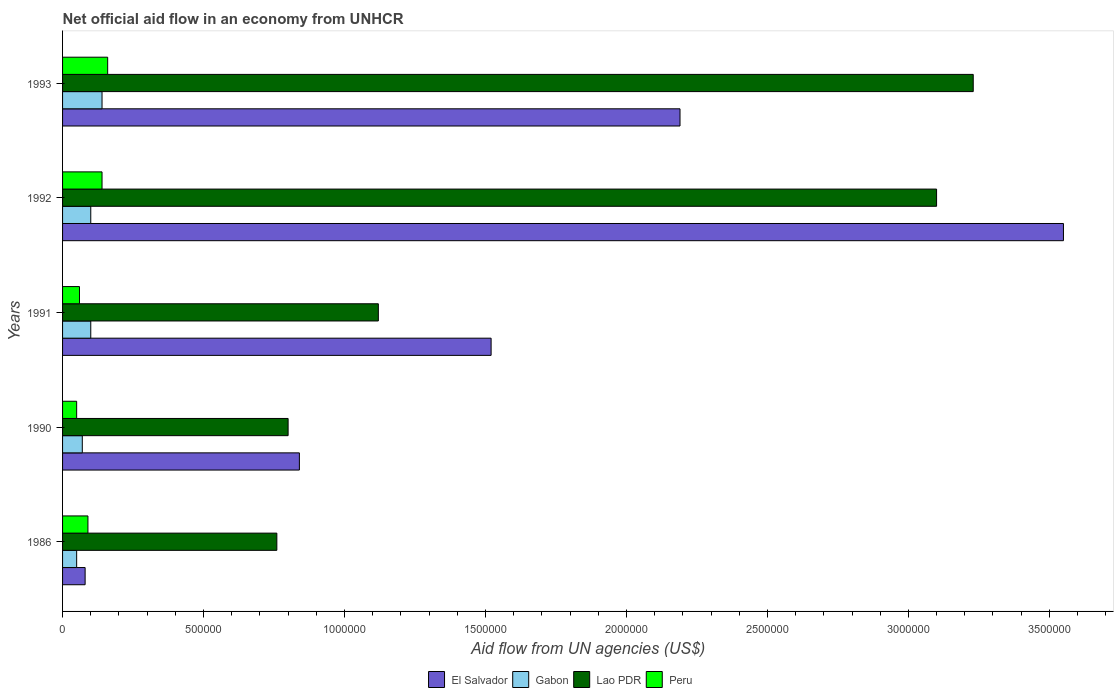How many different coloured bars are there?
Keep it short and to the point. 4. Are the number of bars per tick equal to the number of legend labels?
Make the answer very short. Yes. Are the number of bars on each tick of the Y-axis equal?
Your answer should be compact. Yes. What is the label of the 4th group of bars from the top?
Provide a short and direct response. 1990. What is the net official aid flow in Lao PDR in 1986?
Your response must be concise. 7.60e+05. Across all years, what is the maximum net official aid flow in El Salvador?
Offer a very short reply. 3.55e+06. In which year was the net official aid flow in El Salvador minimum?
Your response must be concise. 1986. What is the difference between the net official aid flow in Gabon in 1990 and that in 1991?
Your answer should be compact. -3.00e+04. What is the difference between the net official aid flow in Gabon in 1993 and the net official aid flow in Peru in 1991?
Your answer should be compact. 8.00e+04. What is the average net official aid flow in El Salvador per year?
Your answer should be compact. 1.64e+06. In the year 1992, what is the difference between the net official aid flow in Gabon and net official aid flow in Peru?
Your answer should be very brief. -4.00e+04. What is the ratio of the net official aid flow in Lao PDR in 1990 to that in 1992?
Ensure brevity in your answer.  0.26. What is the difference between the highest and the second highest net official aid flow in Lao PDR?
Offer a terse response. 1.30e+05. What is the difference between the highest and the lowest net official aid flow in Gabon?
Give a very brief answer. 9.00e+04. Is the sum of the net official aid flow in Lao PDR in 1986 and 1993 greater than the maximum net official aid flow in Peru across all years?
Ensure brevity in your answer.  Yes. Is it the case that in every year, the sum of the net official aid flow in El Salvador and net official aid flow in Peru is greater than the sum of net official aid flow in Lao PDR and net official aid flow in Gabon?
Provide a short and direct response. Yes. What does the 4th bar from the top in 1986 represents?
Provide a succinct answer. El Salvador. What does the 1st bar from the bottom in 1992 represents?
Keep it short and to the point. El Salvador. Is it the case that in every year, the sum of the net official aid flow in Lao PDR and net official aid flow in Gabon is greater than the net official aid flow in El Salvador?
Your answer should be very brief. No. Are all the bars in the graph horizontal?
Your response must be concise. Yes. How many years are there in the graph?
Offer a very short reply. 5. What is the difference between two consecutive major ticks on the X-axis?
Ensure brevity in your answer.  5.00e+05. Does the graph contain any zero values?
Offer a terse response. No. Does the graph contain grids?
Offer a very short reply. No. How many legend labels are there?
Provide a succinct answer. 4. What is the title of the graph?
Provide a short and direct response. Net official aid flow in an economy from UNHCR. What is the label or title of the X-axis?
Ensure brevity in your answer.  Aid flow from UN agencies (US$). What is the Aid flow from UN agencies (US$) in Gabon in 1986?
Ensure brevity in your answer.  5.00e+04. What is the Aid flow from UN agencies (US$) in Lao PDR in 1986?
Provide a short and direct response. 7.60e+05. What is the Aid flow from UN agencies (US$) of Peru in 1986?
Provide a short and direct response. 9.00e+04. What is the Aid flow from UN agencies (US$) of El Salvador in 1990?
Provide a succinct answer. 8.40e+05. What is the Aid flow from UN agencies (US$) in El Salvador in 1991?
Keep it short and to the point. 1.52e+06. What is the Aid flow from UN agencies (US$) in Gabon in 1991?
Ensure brevity in your answer.  1.00e+05. What is the Aid flow from UN agencies (US$) in Lao PDR in 1991?
Make the answer very short. 1.12e+06. What is the Aid flow from UN agencies (US$) of El Salvador in 1992?
Offer a very short reply. 3.55e+06. What is the Aid flow from UN agencies (US$) of Gabon in 1992?
Offer a very short reply. 1.00e+05. What is the Aid flow from UN agencies (US$) in Lao PDR in 1992?
Provide a short and direct response. 3.10e+06. What is the Aid flow from UN agencies (US$) in El Salvador in 1993?
Give a very brief answer. 2.19e+06. What is the Aid flow from UN agencies (US$) in Gabon in 1993?
Keep it short and to the point. 1.40e+05. What is the Aid flow from UN agencies (US$) in Lao PDR in 1993?
Provide a short and direct response. 3.23e+06. What is the Aid flow from UN agencies (US$) in Peru in 1993?
Ensure brevity in your answer.  1.60e+05. Across all years, what is the maximum Aid flow from UN agencies (US$) of El Salvador?
Your answer should be compact. 3.55e+06. Across all years, what is the maximum Aid flow from UN agencies (US$) in Gabon?
Ensure brevity in your answer.  1.40e+05. Across all years, what is the maximum Aid flow from UN agencies (US$) in Lao PDR?
Make the answer very short. 3.23e+06. Across all years, what is the maximum Aid flow from UN agencies (US$) of Peru?
Keep it short and to the point. 1.60e+05. Across all years, what is the minimum Aid flow from UN agencies (US$) in El Salvador?
Offer a terse response. 8.00e+04. Across all years, what is the minimum Aid flow from UN agencies (US$) of Gabon?
Offer a terse response. 5.00e+04. Across all years, what is the minimum Aid flow from UN agencies (US$) of Lao PDR?
Your response must be concise. 7.60e+05. Across all years, what is the minimum Aid flow from UN agencies (US$) in Peru?
Your answer should be very brief. 5.00e+04. What is the total Aid flow from UN agencies (US$) in El Salvador in the graph?
Offer a very short reply. 8.18e+06. What is the total Aid flow from UN agencies (US$) in Lao PDR in the graph?
Ensure brevity in your answer.  9.01e+06. What is the difference between the Aid flow from UN agencies (US$) in El Salvador in 1986 and that in 1990?
Offer a terse response. -7.60e+05. What is the difference between the Aid flow from UN agencies (US$) in Peru in 1986 and that in 1990?
Offer a very short reply. 4.00e+04. What is the difference between the Aid flow from UN agencies (US$) of El Salvador in 1986 and that in 1991?
Provide a succinct answer. -1.44e+06. What is the difference between the Aid flow from UN agencies (US$) in Gabon in 1986 and that in 1991?
Give a very brief answer. -5.00e+04. What is the difference between the Aid flow from UN agencies (US$) in Lao PDR in 1986 and that in 1991?
Make the answer very short. -3.60e+05. What is the difference between the Aid flow from UN agencies (US$) of El Salvador in 1986 and that in 1992?
Make the answer very short. -3.47e+06. What is the difference between the Aid flow from UN agencies (US$) of Gabon in 1986 and that in 1992?
Your answer should be compact. -5.00e+04. What is the difference between the Aid flow from UN agencies (US$) of Lao PDR in 1986 and that in 1992?
Provide a succinct answer. -2.34e+06. What is the difference between the Aid flow from UN agencies (US$) in Peru in 1986 and that in 1992?
Give a very brief answer. -5.00e+04. What is the difference between the Aid flow from UN agencies (US$) in El Salvador in 1986 and that in 1993?
Your response must be concise. -2.11e+06. What is the difference between the Aid flow from UN agencies (US$) of Gabon in 1986 and that in 1993?
Ensure brevity in your answer.  -9.00e+04. What is the difference between the Aid flow from UN agencies (US$) in Lao PDR in 1986 and that in 1993?
Give a very brief answer. -2.47e+06. What is the difference between the Aid flow from UN agencies (US$) of El Salvador in 1990 and that in 1991?
Your answer should be very brief. -6.80e+05. What is the difference between the Aid flow from UN agencies (US$) of Lao PDR in 1990 and that in 1991?
Offer a terse response. -3.20e+05. What is the difference between the Aid flow from UN agencies (US$) of El Salvador in 1990 and that in 1992?
Your response must be concise. -2.71e+06. What is the difference between the Aid flow from UN agencies (US$) in Lao PDR in 1990 and that in 1992?
Make the answer very short. -2.30e+06. What is the difference between the Aid flow from UN agencies (US$) of El Salvador in 1990 and that in 1993?
Provide a short and direct response. -1.35e+06. What is the difference between the Aid flow from UN agencies (US$) of Gabon in 1990 and that in 1993?
Give a very brief answer. -7.00e+04. What is the difference between the Aid flow from UN agencies (US$) in Lao PDR in 1990 and that in 1993?
Ensure brevity in your answer.  -2.43e+06. What is the difference between the Aid flow from UN agencies (US$) of El Salvador in 1991 and that in 1992?
Offer a terse response. -2.03e+06. What is the difference between the Aid flow from UN agencies (US$) in Lao PDR in 1991 and that in 1992?
Keep it short and to the point. -1.98e+06. What is the difference between the Aid flow from UN agencies (US$) of El Salvador in 1991 and that in 1993?
Your answer should be very brief. -6.70e+05. What is the difference between the Aid flow from UN agencies (US$) of Gabon in 1991 and that in 1993?
Make the answer very short. -4.00e+04. What is the difference between the Aid flow from UN agencies (US$) in Lao PDR in 1991 and that in 1993?
Provide a succinct answer. -2.11e+06. What is the difference between the Aid flow from UN agencies (US$) of El Salvador in 1992 and that in 1993?
Make the answer very short. 1.36e+06. What is the difference between the Aid flow from UN agencies (US$) of Gabon in 1992 and that in 1993?
Ensure brevity in your answer.  -4.00e+04. What is the difference between the Aid flow from UN agencies (US$) in Peru in 1992 and that in 1993?
Your answer should be very brief. -2.00e+04. What is the difference between the Aid flow from UN agencies (US$) of El Salvador in 1986 and the Aid flow from UN agencies (US$) of Lao PDR in 1990?
Keep it short and to the point. -7.20e+05. What is the difference between the Aid flow from UN agencies (US$) in Gabon in 1986 and the Aid flow from UN agencies (US$) in Lao PDR in 1990?
Your response must be concise. -7.50e+05. What is the difference between the Aid flow from UN agencies (US$) of Lao PDR in 1986 and the Aid flow from UN agencies (US$) of Peru in 1990?
Provide a short and direct response. 7.10e+05. What is the difference between the Aid flow from UN agencies (US$) in El Salvador in 1986 and the Aid flow from UN agencies (US$) in Lao PDR in 1991?
Your response must be concise. -1.04e+06. What is the difference between the Aid flow from UN agencies (US$) of El Salvador in 1986 and the Aid flow from UN agencies (US$) of Peru in 1991?
Your answer should be compact. 2.00e+04. What is the difference between the Aid flow from UN agencies (US$) of Gabon in 1986 and the Aid flow from UN agencies (US$) of Lao PDR in 1991?
Provide a short and direct response. -1.07e+06. What is the difference between the Aid flow from UN agencies (US$) of Lao PDR in 1986 and the Aid flow from UN agencies (US$) of Peru in 1991?
Your response must be concise. 7.00e+05. What is the difference between the Aid flow from UN agencies (US$) in El Salvador in 1986 and the Aid flow from UN agencies (US$) in Lao PDR in 1992?
Your answer should be compact. -3.02e+06. What is the difference between the Aid flow from UN agencies (US$) in Gabon in 1986 and the Aid flow from UN agencies (US$) in Lao PDR in 1992?
Give a very brief answer. -3.05e+06. What is the difference between the Aid flow from UN agencies (US$) of Gabon in 1986 and the Aid flow from UN agencies (US$) of Peru in 1992?
Ensure brevity in your answer.  -9.00e+04. What is the difference between the Aid flow from UN agencies (US$) in Lao PDR in 1986 and the Aid flow from UN agencies (US$) in Peru in 1992?
Provide a short and direct response. 6.20e+05. What is the difference between the Aid flow from UN agencies (US$) of El Salvador in 1986 and the Aid flow from UN agencies (US$) of Gabon in 1993?
Your answer should be compact. -6.00e+04. What is the difference between the Aid flow from UN agencies (US$) in El Salvador in 1986 and the Aid flow from UN agencies (US$) in Lao PDR in 1993?
Your response must be concise. -3.15e+06. What is the difference between the Aid flow from UN agencies (US$) in Gabon in 1986 and the Aid flow from UN agencies (US$) in Lao PDR in 1993?
Provide a short and direct response. -3.18e+06. What is the difference between the Aid flow from UN agencies (US$) of Gabon in 1986 and the Aid flow from UN agencies (US$) of Peru in 1993?
Provide a succinct answer. -1.10e+05. What is the difference between the Aid flow from UN agencies (US$) of Lao PDR in 1986 and the Aid flow from UN agencies (US$) of Peru in 1993?
Your response must be concise. 6.00e+05. What is the difference between the Aid flow from UN agencies (US$) in El Salvador in 1990 and the Aid flow from UN agencies (US$) in Gabon in 1991?
Your response must be concise. 7.40e+05. What is the difference between the Aid flow from UN agencies (US$) in El Salvador in 1990 and the Aid flow from UN agencies (US$) in Lao PDR in 1991?
Ensure brevity in your answer.  -2.80e+05. What is the difference between the Aid flow from UN agencies (US$) of El Salvador in 1990 and the Aid flow from UN agencies (US$) of Peru in 1991?
Make the answer very short. 7.80e+05. What is the difference between the Aid flow from UN agencies (US$) in Gabon in 1990 and the Aid flow from UN agencies (US$) in Lao PDR in 1991?
Offer a terse response. -1.05e+06. What is the difference between the Aid flow from UN agencies (US$) of Lao PDR in 1990 and the Aid flow from UN agencies (US$) of Peru in 1991?
Provide a succinct answer. 7.40e+05. What is the difference between the Aid flow from UN agencies (US$) in El Salvador in 1990 and the Aid flow from UN agencies (US$) in Gabon in 1992?
Offer a very short reply. 7.40e+05. What is the difference between the Aid flow from UN agencies (US$) of El Salvador in 1990 and the Aid flow from UN agencies (US$) of Lao PDR in 1992?
Give a very brief answer. -2.26e+06. What is the difference between the Aid flow from UN agencies (US$) of El Salvador in 1990 and the Aid flow from UN agencies (US$) of Peru in 1992?
Offer a terse response. 7.00e+05. What is the difference between the Aid flow from UN agencies (US$) of Gabon in 1990 and the Aid flow from UN agencies (US$) of Lao PDR in 1992?
Ensure brevity in your answer.  -3.03e+06. What is the difference between the Aid flow from UN agencies (US$) in Gabon in 1990 and the Aid flow from UN agencies (US$) in Peru in 1992?
Give a very brief answer. -7.00e+04. What is the difference between the Aid flow from UN agencies (US$) of Lao PDR in 1990 and the Aid flow from UN agencies (US$) of Peru in 1992?
Provide a short and direct response. 6.60e+05. What is the difference between the Aid flow from UN agencies (US$) in El Salvador in 1990 and the Aid flow from UN agencies (US$) in Gabon in 1993?
Your response must be concise. 7.00e+05. What is the difference between the Aid flow from UN agencies (US$) of El Salvador in 1990 and the Aid flow from UN agencies (US$) of Lao PDR in 1993?
Offer a terse response. -2.39e+06. What is the difference between the Aid flow from UN agencies (US$) of El Salvador in 1990 and the Aid flow from UN agencies (US$) of Peru in 1993?
Make the answer very short. 6.80e+05. What is the difference between the Aid flow from UN agencies (US$) in Gabon in 1990 and the Aid flow from UN agencies (US$) in Lao PDR in 1993?
Give a very brief answer. -3.16e+06. What is the difference between the Aid flow from UN agencies (US$) of Lao PDR in 1990 and the Aid flow from UN agencies (US$) of Peru in 1993?
Provide a succinct answer. 6.40e+05. What is the difference between the Aid flow from UN agencies (US$) of El Salvador in 1991 and the Aid flow from UN agencies (US$) of Gabon in 1992?
Offer a terse response. 1.42e+06. What is the difference between the Aid flow from UN agencies (US$) of El Salvador in 1991 and the Aid flow from UN agencies (US$) of Lao PDR in 1992?
Your answer should be compact. -1.58e+06. What is the difference between the Aid flow from UN agencies (US$) of El Salvador in 1991 and the Aid flow from UN agencies (US$) of Peru in 1992?
Provide a short and direct response. 1.38e+06. What is the difference between the Aid flow from UN agencies (US$) in Gabon in 1991 and the Aid flow from UN agencies (US$) in Lao PDR in 1992?
Offer a very short reply. -3.00e+06. What is the difference between the Aid flow from UN agencies (US$) of Gabon in 1991 and the Aid flow from UN agencies (US$) of Peru in 1992?
Offer a terse response. -4.00e+04. What is the difference between the Aid flow from UN agencies (US$) of Lao PDR in 1991 and the Aid flow from UN agencies (US$) of Peru in 1992?
Provide a succinct answer. 9.80e+05. What is the difference between the Aid flow from UN agencies (US$) of El Salvador in 1991 and the Aid flow from UN agencies (US$) of Gabon in 1993?
Your answer should be compact. 1.38e+06. What is the difference between the Aid flow from UN agencies (US$) of El Salvador in 1991 and the Aid flow from UN agencies (US$) of Lao PDR in 1993?
Make the answer very short. -1.71e+06. What is the difference between the Aid flow from UN agencies (US$) of El Salvador in 1991 and the Aid flow from UN agencies (US$) of Peru in 1993?
Make the answer very short. 1.36e+06. What is the difference between the Aid flow from UN agencies (US$) of Gabon in 1991 and the Aid flow from UN agencies (US$) of Lao PDR in 1993?
Your answer should be very brief. -3.13e+06. What is the difference between the Aid flow from UN agencies (US$) in Lao PDR in 1991 and the Aid flow from UN agencies (US$) in Peru in 1993?
Ensure brevity in your answer.  9.60e+05. What is the difference between the Aid flow from UN agencies (US$) of El Salvador in 1992 and the Aid flow from UN agencies (US$) of Gabon in 1993?
Offer a terse response. 3.41e+06. What is the difference between the Aid flow from UN agencies (US$) of El Salvador in 1992 and the Aid flow from UN agencies (US$) of Lao PDR in 1993?
Give a very brief answer. 3.20e+05. What is the difference between the Aid flow from UN agencies (US$) of El Salvador in 1992 and the Aid flow from UN agencies (US$) of Peru in 1993?
Your answer should be very brief. 3.39e+06. What is the difference between the Aid flow from UN agencies (US$) of Gabon in 1992 and the Aid flow from UN agencies (US$) of Lao PDR in 1993?
Ensure brevity in your answer.  -3.13e+06. What is the difference between the Aid flow from UN agencies (US$) of Gabon in 1992 and the Aid flow from UN agencies (US$) of Peru in 1993?
Provide a short and direct response. -6.00e+04. What is the difference between the Aid flow from UN agencies (US$) of Lao PDR in 1992 and the Aid flow from UN agencies (US$) of Peru in 1993?
Offer a very short reply. 2.94e+06. What is the average Aid flow from UN agencies (US$) of El Salvador per year?
Offer a very short reply. 1.64e+06. What is the average Aid flow from UN agencies (US$) in Gabon per year?
Keep it short and to the point. 9.20e+04. What is the average Aid flow from UN agencies (US$) of Lao PDR per year?
Provide a succinct answer. 1.80e+06. In the year 1986, what is the difference between the Aid flow from UN agencies (US$) in El Salvador and Aid flow from UN agencies (US$) in Gabon?
Offer a terse response. 3.00e+04. In the year 1986, what is the difference between the Aid flow from UN agencies (US$) in El Salvador and Aid flow from UN agencies (US$) in Lao PDR?
Offer a terse response. -6.80e+05. In the year 1986, what is the difference between the Aid flow from UN agencies (US$) in El Salvador and Aid flow from UN agencies (US$) in Peru?
Offer a very short reply. -10000. In the year 1986, what is the difference between the Aid flow from UN agencies (US$) of Gabon and Aid flow from UN agencies (US$) of Lao PDR?
Ensure brevity in your answer.  -7.10e+05. In the year 1986, what is the difference between the Aid flow from UN agencies (US$) in Gabon and Aid flow from UN agencies (US$) in Peru?
Give a very brief answer. -4.00e+04. In the year 1986, what is the difference between the Aid flow from UN agencies (US$) of Lao PDR and Aid flow from UN agencies (US$) of Peru?
Your answer should be very brief. 6.70e+05. In the year 1990, what is the difference between the Aid flow from UN agencies (US$) in El Salvador and Aid flow from UN agencies (US$) in Gabon?
Your response must be concise. 7.70e+05. In the year 1990, what is the difference between the Aid flow from UN agencies (US$) of El Salvador and Aid flow from UN agencies (US$) of Peru?
Make the answer very short. 7.90e+05. In the year 1990, what is the difference between the Aid flow from UN agencies (US$) in Gabon and Aid flow from UN agencies (US$) in Lao PDR?
Provide a succinct answer. -7.30e+05. In the year 1990, what is the difference between the Aid flow from UN agencies (US$) in Lao PDR and Aid flow from UN agencies (US$) in Peru?
Make the answer very short. 7.50e+05. In the year 1991, what is the difference between the Aid flow from UN agencies (US$) in El Salvador and Aid flow from UN agencies (US$) in Gabon?
Offer a terse response. 1.42e+06. In the year 1991, what is the difference between the Aid flow from UN agencies (US$) of El Salvador and Aid flow from UN agencies (US$) of Lao PDR?
Give a very brief answer. 4.00e+05. In the year 1991, what is the difference between the Aid flow from UN agencies (US$) in El Salvador and Aid flow from UN agencies (US$) in Peru?
Your answer should be compact. 1.46e+06. In the year 1991, what is the difference between the Aid flow from UN agencies (US$) in Gabon and Aid flow from UN agencies (US$) in Lao PDR?
Your answer should be compact. -1.02e+06. In the year 1991, what is the difference between the Aid flow from UN agencies (US$) of Gabon and Aid flow from UN agencies (US$) of Peru?
Ensure brevity in your answer.  4.00e+04. In the year 1991, what is the difference between the Aid flow from UN agencies (US$) in Lao PDR and Aid flow from UN agencies (US$) in Peru?
Offer a terse response. 1.06e+06. In the year 1992, what is the difference between the Aid flow from UN agencies (US$) in El Salvador and Aid flow from UN agencies (US$) in Gabon?
Provide a succinct answer. 3.45e+06. In the year 1992, what is the difference between the Aid flow from UN agencies (US$) of El Salvador and Aid flow from UN agencies (US$) of Peru?
Your response must be concise. 3.41e+06. In the year 1992, what is the difference between the Aid flow from UN agencies (US$) in Gabon and Aid flow from UN agencies (US$) in Lao PDR?
Provide a succinct answer. -3.00e+06. In the year 1992, what is the difference between the Aid flow from UN agencies (US$) in Lao PDR and Aid flow from UN agencies (US$) in Peru?
Your response must be concise. 2.96e+06. In the year 1993, what is the difference between the Aid flow from UN agencies (US$) of El Salvador and Aid flow from UN agencies (US$) of Gabon?
Ensure brevity in your answer.  2.05e+06. In the year 1993, what is the difference between the Aid flow from UN agencies (US$) of El Salvador and Aid flow from UN agencies (US$) of Lao PDR?
Keep it short and to the point. -1.04e+06. In the year 1993, what is the difference between the Aid flow from UN agencies (US$) in El Salvador and Aid flow from UN agencies (US$) in Peru?
Your answer should be compact. 2.03e+06. In the year 1993, what is the difference between the Aid flow from UN agencies (US$) in Gabon and Aid flow from UN agencies (US$) in Lao PDR?
Your answer should be very brief. -3.09e+06. In the year 1993, what is the difference between the Aid flow from UN agencies (US$) in Lao PDR and Aid flow from UN agencies (US$) in Peru?
Offer a very short reply. 3.07e+06. What is the ratio of the Aid flow from UN agencies (US$) of El Salvador in 1986 to that in 1990?
Ensure brevity in your answer.  0.1. What is the ratio of the Aid flow from UN agencies (US$) of Gabon in 1986 to that in 1990?
Keep it short and to the point. 0.71. What is the ratio of the Aid flow from UN agencies (US$) of Lao PDR in 1986 to that in 1990?
Keep it short and to the point. 0.95. What is the ratio of the Aid flow from UN agencies (US$) of El Salvador in 1986 to that in 1991?
Offer a terse response. 0.05. What is the ratio of the Aid flow from UN agencies (US$) of Lao PDR in 1986 to that in 1991?
Your answer should be very brief. 0.68. What is the ratio of the Aid flow from UN agencies (US$) of Peru in 1986 to that in 1991?
Provide a short and direct response. 1.5. What is the ratio of the Aid flow from UN agencies (US$) of El Salvador in 1986 to that in 1992?
Ensure brevity in your answer.  0.02. What is the ratio of the Aid flow from UN agencies (US$) in Gabon in 1986 to that in 1992?
Give a very brief answer. 0.5. What is the ratio of the Aid flow from UN agencies (US$) of Lao PDR in 1986 to that in 1992?
Give a very brief answer. 0.25. What is the ratio of the Aid flow from UN agencies (US$) of Peru in 1986 to that in 1992?
Your response must be concise. 0.64. What is the ratio of the Aid flow from UN agencies (US$) of El Salvador in 1986 to that in 1993?
Provide a succinct answer. 0.04. What is the ratio of the Aid flow from UN agencies (US$) of Gabon in 1986 to that in 1993?
Offer a very short reply. 0.36. What is the ratio of the Aid flow from UN agencies (US$) of Lao PDR in 1986 to that in 1993?
Offer a terse response. 0.24. What is the ratio of the Aid flow from UN agencies (US$) of Peru in 1986 to that in 1993?
Give a very brief answer. 0.56. What is the ratio of the Aid flow from UN agencies (US$) of El Salvador in 1990 to that in 1991?
Provide a short and direct response. 0.55. What is the ratio of the Aid flow from UN agencies (US$) of Lao PDR in 1990 to that in 1991?
Offer a terse response. 0.71. What is the ratio of the Aid flow from UN agencies (US$) of Peru in 1990 to that in 1991?
Your answer should be very brief. 0.83. What is the ratio of the Aid flow from UN agencies (US$) of El Salvador in 1990 to that in 1992?
Make the answer very short. 0.24. What is the ratio of the Aid flow from UN agencies (US$) in Gabon in 1990 to that in 1992?
Make the answer very short. 0.7. What is the ratio of the Aid flow from UN agencies (US$) in Lao PDR in 1990 to that in 1992?
Give a very brief answer. 0.26. What is the ratio of the Aid flow from UN agencies (US$) of Peru in 1990 to that in 1992?
Provide a succinct answer. 0.36. What is the ratio of the Aid flow from UN agencies (US$) of El Salvador in 1990 to that in 1993?
Offer a terse response. 0.38. What is the ratio of the Aid flow from UN agencies (US$) in Lao PDR in 1990 to that in 1993?
Make the answer very short. 0.25. What is the ratio of the Aid flow from UN agencies (US$) in Peru in 1990 to that in 1993?
Offer a very short reply. 0.31. What is the ratio of the Aid flow from UN agencies (US$) in El Salvador in 1991 to that in 1992?
Ensure brevity in your answer.  0.43. What is the ratio of the Aid flow from UN agencies (US$) of Gabon in 1991 to that in 1992?
Ensure brevity in your answer.  1. What is the ratio of the Aid flow from UN agencies (US$) in Lao PDR in 1991 to that in 1992?
Ensure brevity in your answer.  0.36. What is the ratio of the Aid flow from UN agencies (US$) in Peru in 1991 to that in 1992?
Provide a succinct answer. 0.43. What is the ratio of the Aid flow from UN agencies (US$) in El Salvador in 1991 to that in 1993?
Make the answer very short. 0.69. What is the ratio of the Aid flow from UN agencies (US$) in Gabon in 1991 to that in 1993?
Provide a short and direct response. 0.71. What is the ratio of the Aid flow from UN agencies (US$) of Lao PDR in 1991 to that in 1993?
Your answer should be very brief. 0.35. What is the ratio of the Aid flow from UN agencies (US$) of Peru in 1991 to that in 1993?
Your answer should be compact. 0.38. What is the ratio of the Aid flow from UN agencies (US$) in El Salvador in 1992 to that in 1993?
Ensure brevity in your answer.  1.62. What is the ratio of the Aid flow from UN agencies (US$) of Gabon in 1992 to that in 1993?
Ensure brevity in your answer.  0.71. What is the ratio of the Aid flow from UN agencies (US$) of Lao PDR in 1992 to that in 1993?
Make the answer very short. 0.96. What is the difference between the highest and the second highest Aid flow from UN agencies (US$) in El Salvador?
Keep it short and to the point. 1.36e+06. What is the difference between the highest and the second highest Aid flow from UN agencies (US$) of Gabon?
Give a very brief answer. 4.00e+04. What is the difference between the highest and the second highest Aid flow from UN agencies (US$) of Lao PDR?
Your answer should be very brief. 1.30e+05. What is the difference between the highest and the lowest Aid flow from UN agencies (US$) of El Salvador?
Provide a short and direct response. 3.47e+06. What is the difference between the highest and the lowest Aid flow from UN agencies (US$) of Gabon?
Provide a short and direct response. 9.00e+04. What is the difference between the highest and the lowest Aid flow from UN agencies (US$) in Lao PDR?
Keep it short and to the point. 2.47e+06. 